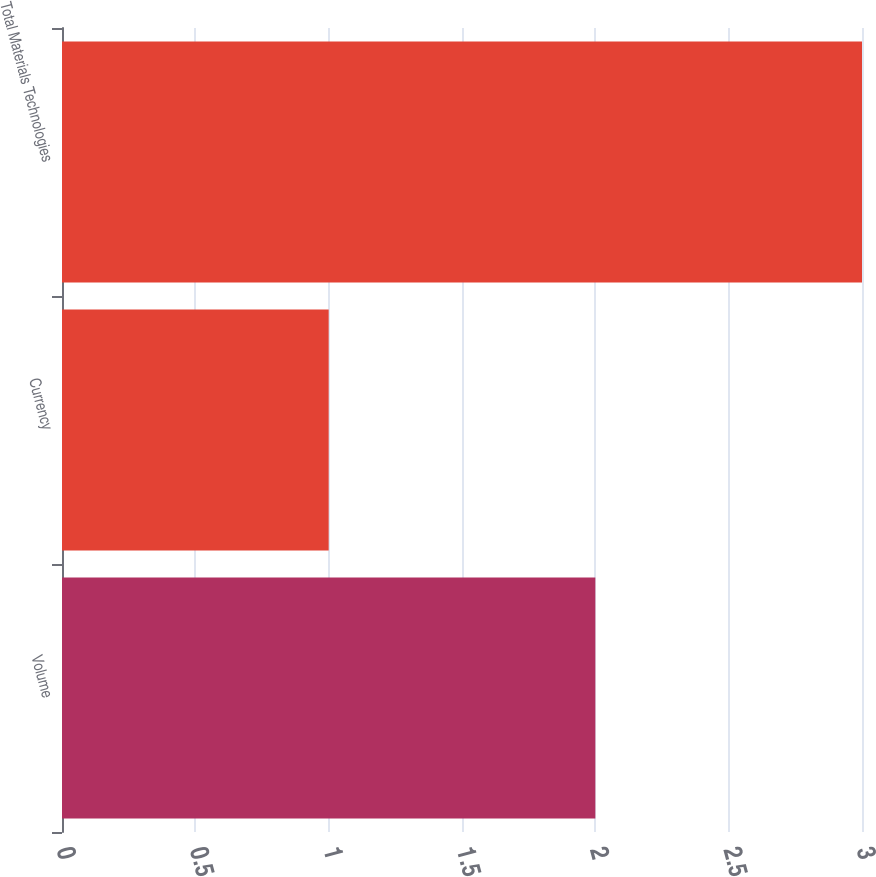Convert chart. <chart><loc_0><loc_0><loc_500><loc_500><bar_chart><fcel>Volume<fcel>Currency<fcel>Total Materials Technologies<nl><fcel>2<fcel>1<fcel>3<nl></chart> 